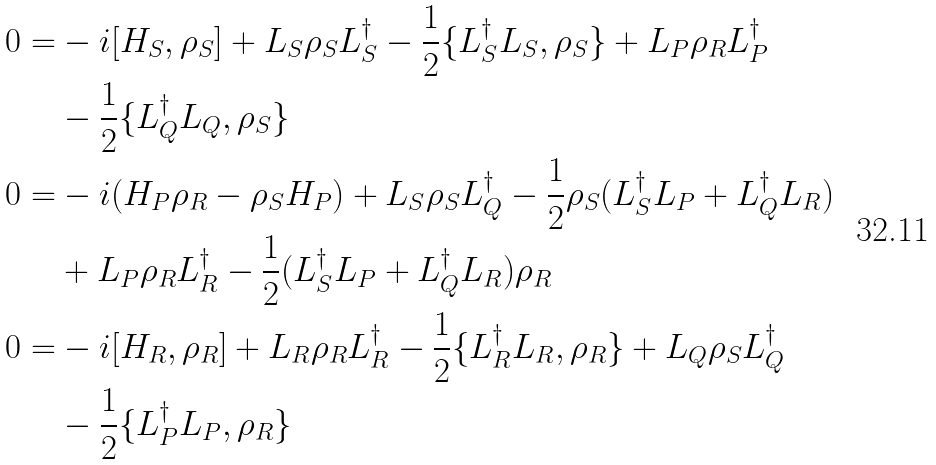<formula> <loc_0><loc_0><loc_500><loc_500>0 = & - i [ H _ { S } , \rho _ { S } ] + L _ { S } \rho _ { S } L _ { S } ^ { \dag } - \frac { 1 } { 2 } \{ L _ { S } ^ { \dag } L _ { S } , \rho _ { S } \} + L _ { P } \rho _ { R } L _ { P } ^ { \dag } \\ & - \frac { 1 } { 2 } \{ L _ { Q } ^ { \dag } L _ { Q } , \rho _ { S } \} \\ 0 = & - i ( H _ { P } \rho _ { R } - \rho _ { S } H _ { P } ) + L _ { S } \rho _ { S } L _ { Q } ^ { \dag } - \frac { 1 } { 2 } \rho _ { S } ( L _ { S } ^ { \dag } L _ { P } + L _ { Q } ^ { \dag } L _ { R } ) \\ & + L _ { P } \rho _ { R } L _ { R } ^ { \dag } - \frac { 1 } { 2 } ( L _ { S } ^ { \dag } L _ { P } + L _ { Q } ^ { \dag } L _ { R } ) \rho _ { R } \\ 0 = & - i [ H _ { R } , \rho _ { R } ] + L _ { R } \rho _ { R } L _ { R } ^ { \dag } - \frac { 1 } { 2 } \{ L _ { R } ^ { \dag } L _ { R } , \rho _ { R } \} + L _ { Q } \rho _ { S } L _ { Q } ^ { \dag } \\ & - \frac { 1 } { 2 } \{ L _ { P } ^ { \dag } L _ { P } , \rho _ { R } \}</formula> 